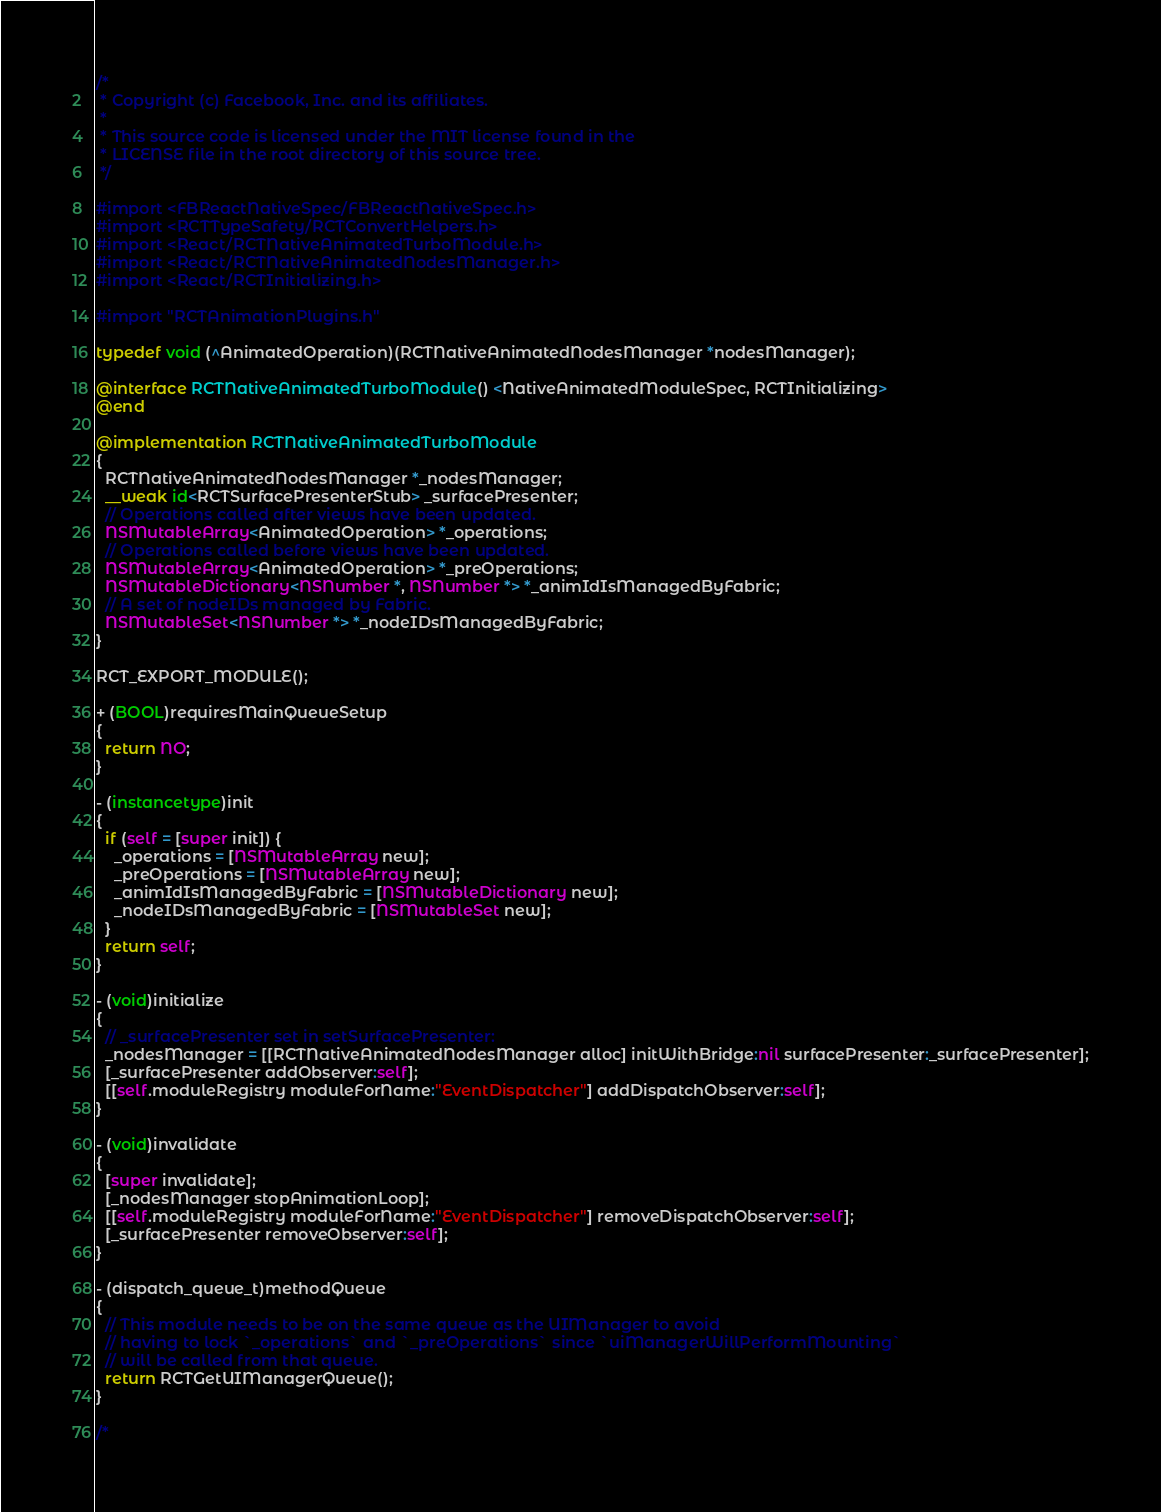Convert code to text. <code><loc_0><loc_0><loc_500><loc_500><_ObjectiveC_>/*
 * Copyright (c) Facebook, Inc. and its affiliates.
 *
 * This source code is licensed under the MIT license found in the
 * LICENSE file in the root directory of this source tree.
 */

#import <FBReactNativeSpec/FBReactNativeSpec.h>
#import <RCTTypeSafety/RCTConvertHelpers.h>
#import <React/RCTNativeAnimatedTurboModule.h>
#import <React/RCTNativeAnimatedNodesManager.h>
#import <React/RCTInitializing.h>

#import "RCTAnimationPlugins.h"

typedef void (^AnimatedOperation)(RCTNativeAnimatedNodesManager *nodesManager);

@interface RCTNativeAnimatedTurboModule() <NativeAnimatedModuleSpec, RCTInitializing>
@end

@implementation RCTNativeAnimatedTurboModule
{
  RCTNativeAnimatedNodesManager *_nodesManager;
  __weak id<RCTSurfacePresenterStub> _surfacePresenter;
  // Operations called after views have been updated.
  NSMutableArray<AnimatedOperation> *_operations;
  // Operations called before views have been updated.
  NSMutableArray<AnimatedOperation> *_preOperations;
  NSMutableDictionary<NSNumber *, NSNumber *> *_animIdIsManagedByFabric;
  // A set of nodeIDs managed by Fabric.
  NSMutableSet<NSNumber *> *_nodeIDsManagedByFabric;
}

RCT_EXPORT_MODULE();

+ (BOOL)requiresMainQueueSetup
{
  return NO;
}

- (instancetype)init
{
  if (self = [super init]) {
    _operations = [NSMutableArray new];
    _preOperations = [NSMutableArray new];
    _animIdIsManagedByFabric = [NSMutableDictionary new];
    _nodeIDsManagedByFabric = [NSMutableSet new];
  }
  return self;
}

- (void)initialize
{
  // _surfacePresenter set in setSurfacePresenter:
  _nodesManager = [[RCTNativeAnimatedNodesManager alloc] initWithBridge:nil surfacePresenter:_surfacePresenter];
  [_surfacePresenter addObserver:self];
  [[self.moduleRegistry moduleForName:"EventDispatcher"] addDispatchObserver:self];
}

- (void)invalidate
{
  [super invalidate];
  [_nodesManager stopAnimationLoop];
  [[self.moduleRegistry moduleForName:"EventDispatcher"] removeDispatchObserver:self];
  [_surfacePresenter removeObserver:self];
}

- (dispatch_queue_t)methodQueue
{
  // This module needs to be on the same queue as the UIManager to avoid
  // having to lock `_operations` and `_preOperations` since `uiManagerWillPerformMounting`
  // will be called from that queue.
  return RCTGetUIManagerQueue();
}

/*</code> 